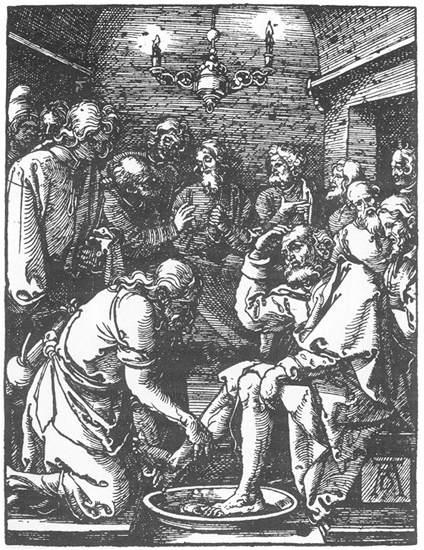Write a detailed description of the given image. This image is a highly detailed black and white illustration that is reminiscent of an etching or woodcut style. It appears to depict a historical or religious moment within a brick-walled room, creating a sense of an intimate and significant setting. A notable chandelier hangs from the ceiling, providing a focal point that further enriches the ambiance.

The central focus of the image is a solemn scene where a group of individuals, all adorned in robes and hats indicative of the period or a religious order, are gathered around a significant act of foot washing. The man performing the foot washing is kneeling, displaying a gesture of humility and service, which suggests a deeply reverent or significant event. The surrounding individuals are observing with somber expressions, adding to the overall mood of solemnity and reverence. The use of monochromatic tones and the intricate style of the illustration amplify the gravity and seriousness of the depicted scene. 